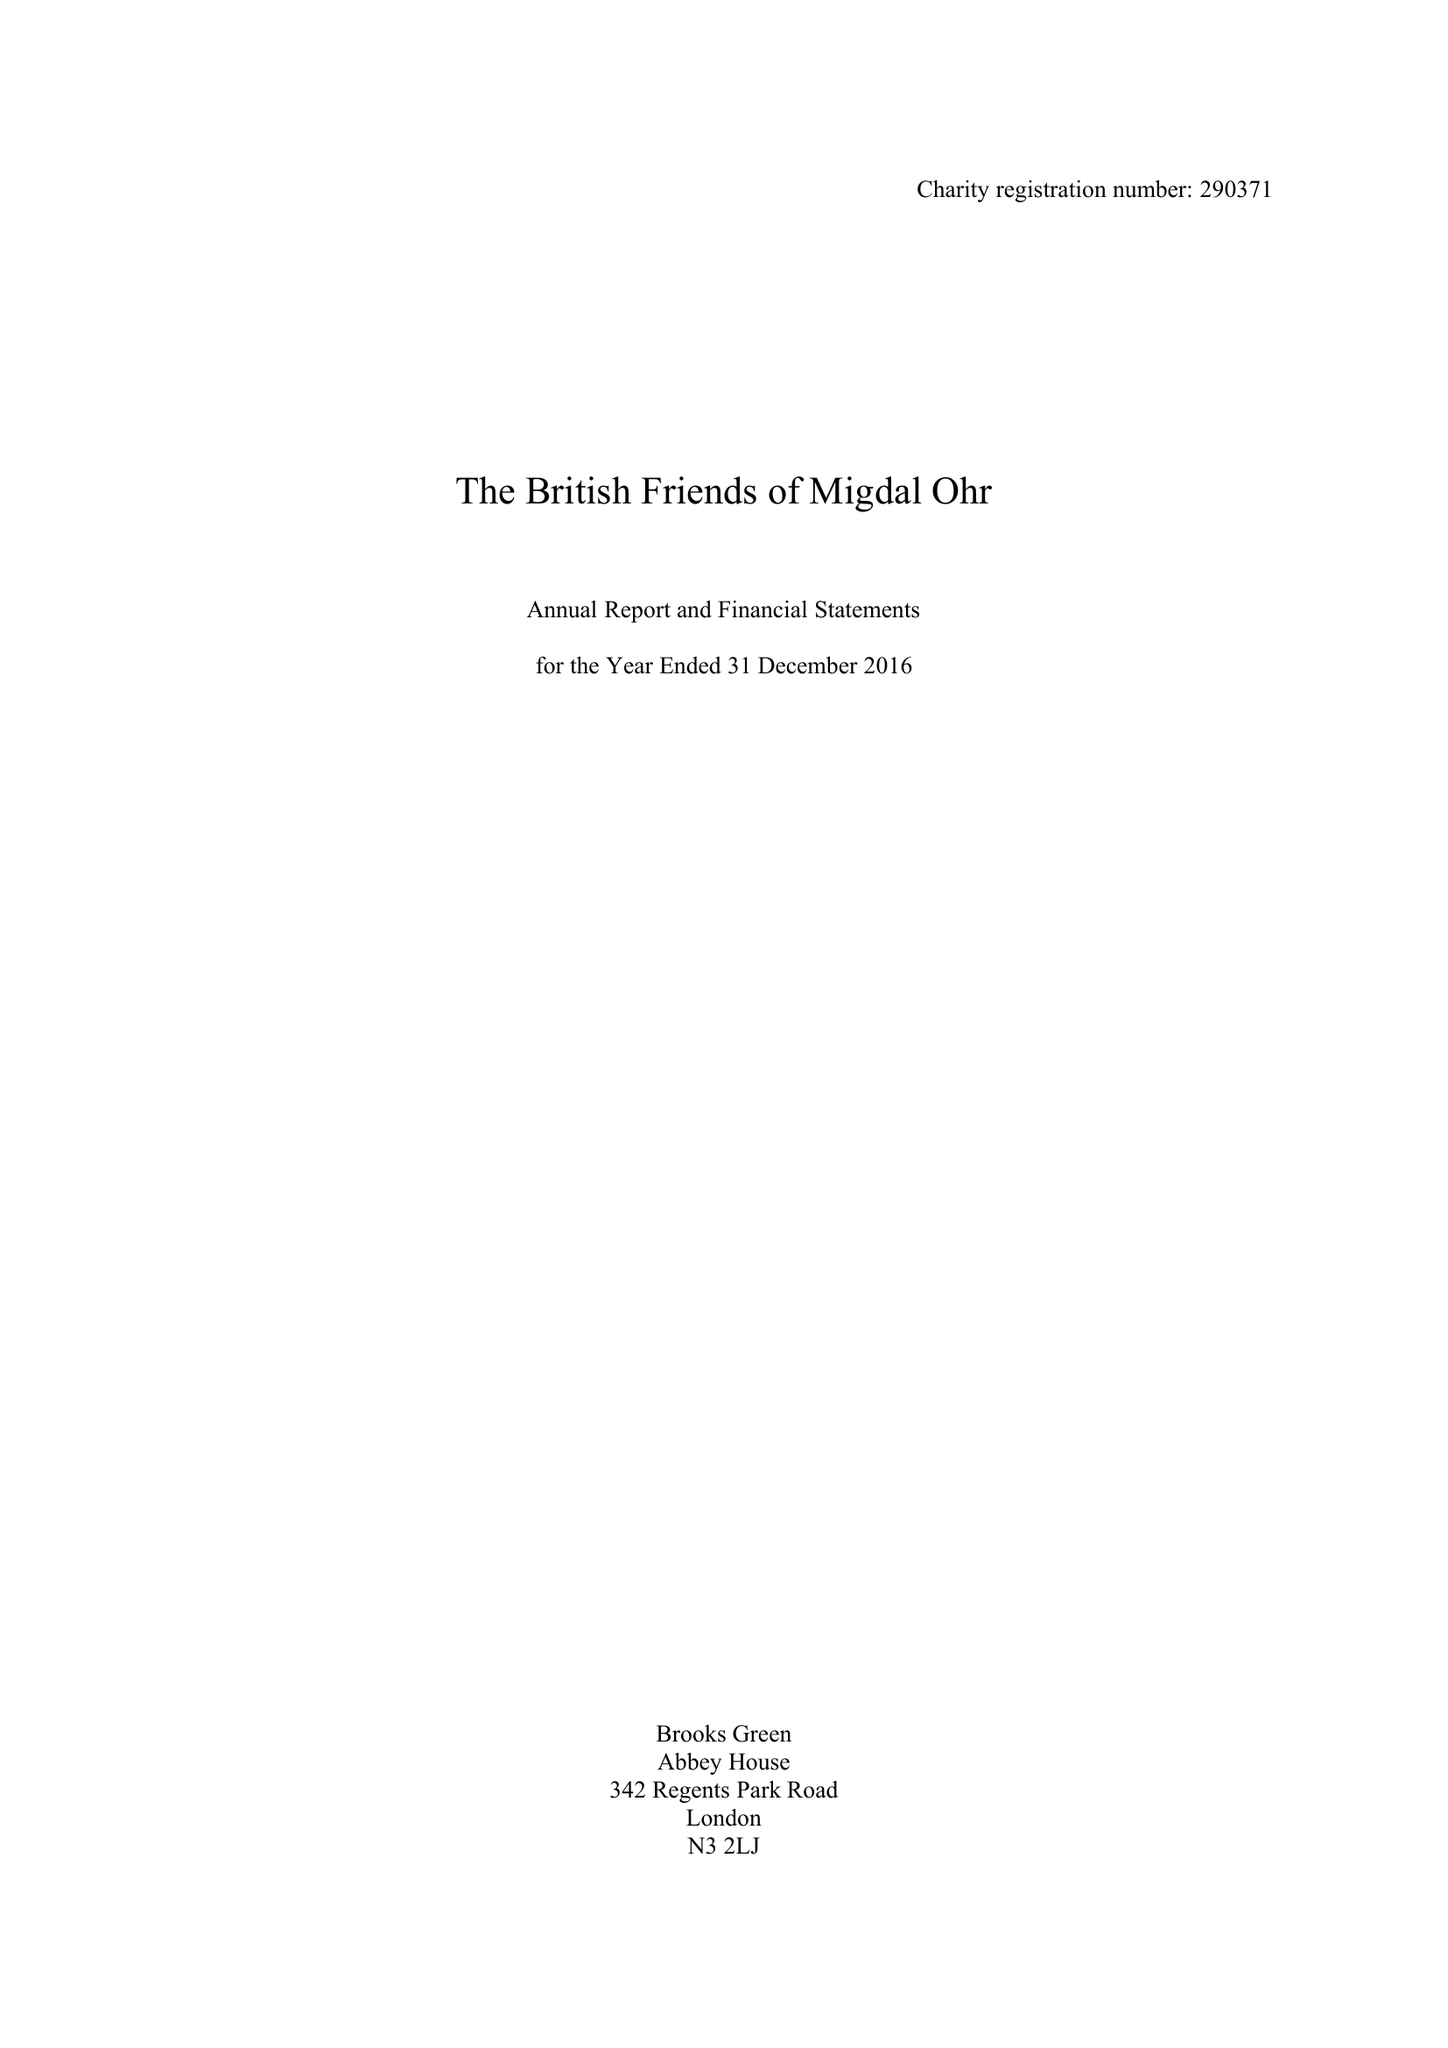What is the value for the charity_number?
Answer the question using a single word or phrase. 290371 